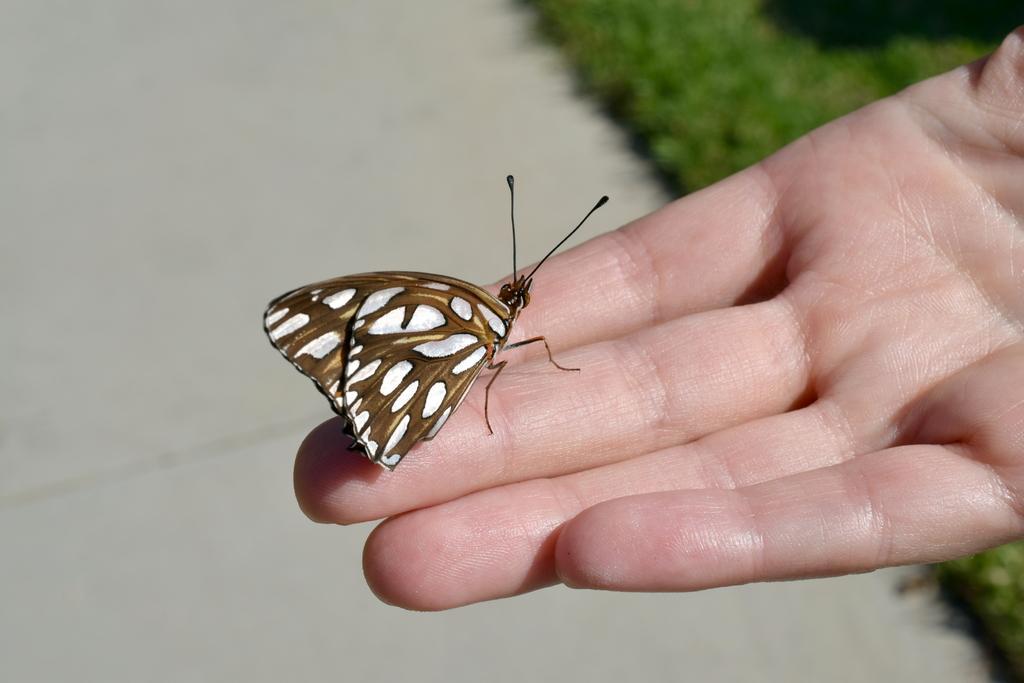Please provide a concise description of this image. This picture is clicked outside. In the center we can see the moth on the hand of a person. In the background we can see the ground and the green grass. 